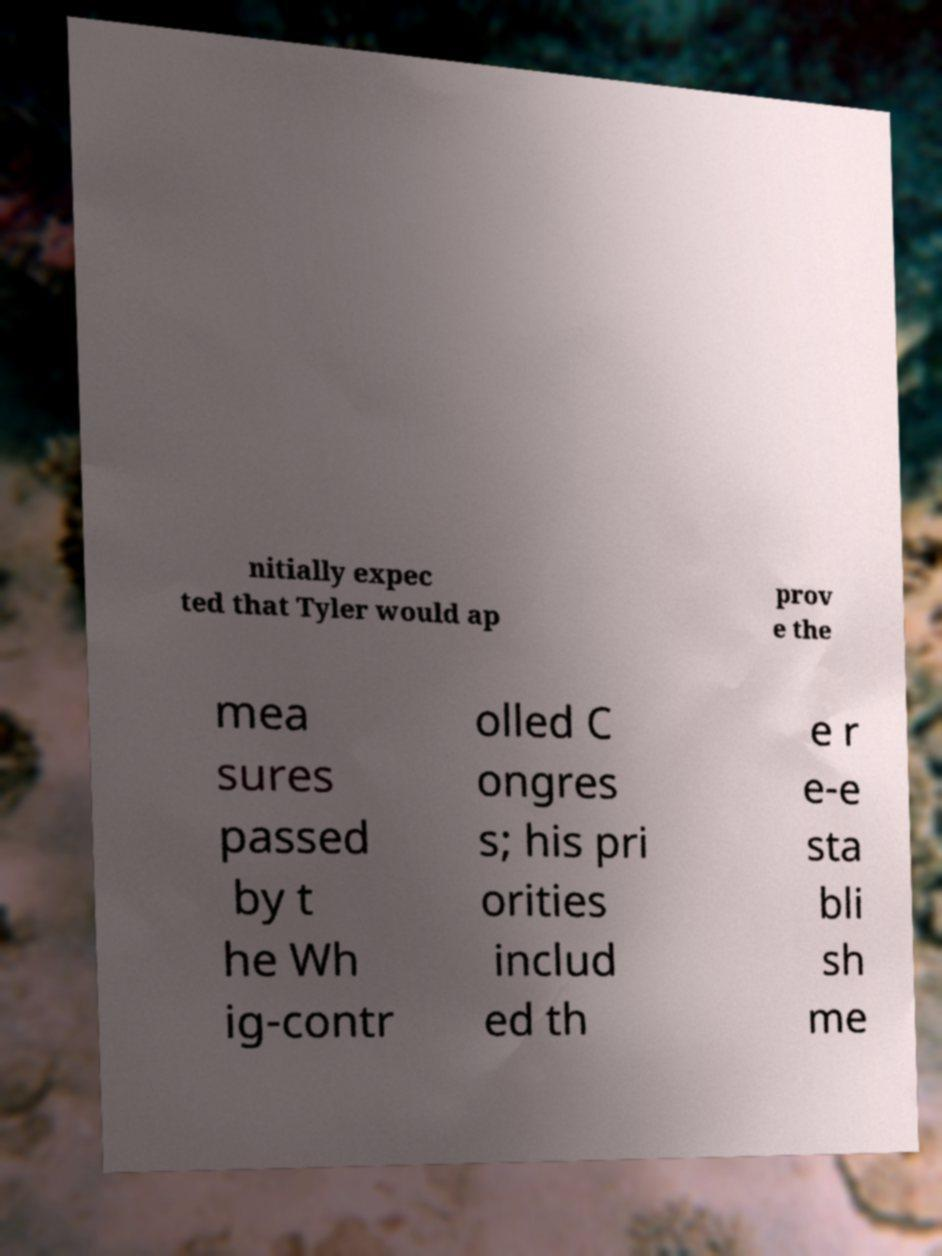There's text embedded in this image that I need extracted. Can you transcribe it verbatim? nitially expec ted that Tyler would ap prov e the mea sures passed by t he Wh ig-contr olled C ongres s; his pri orities includ ed th e r e-e sta bli sh me 